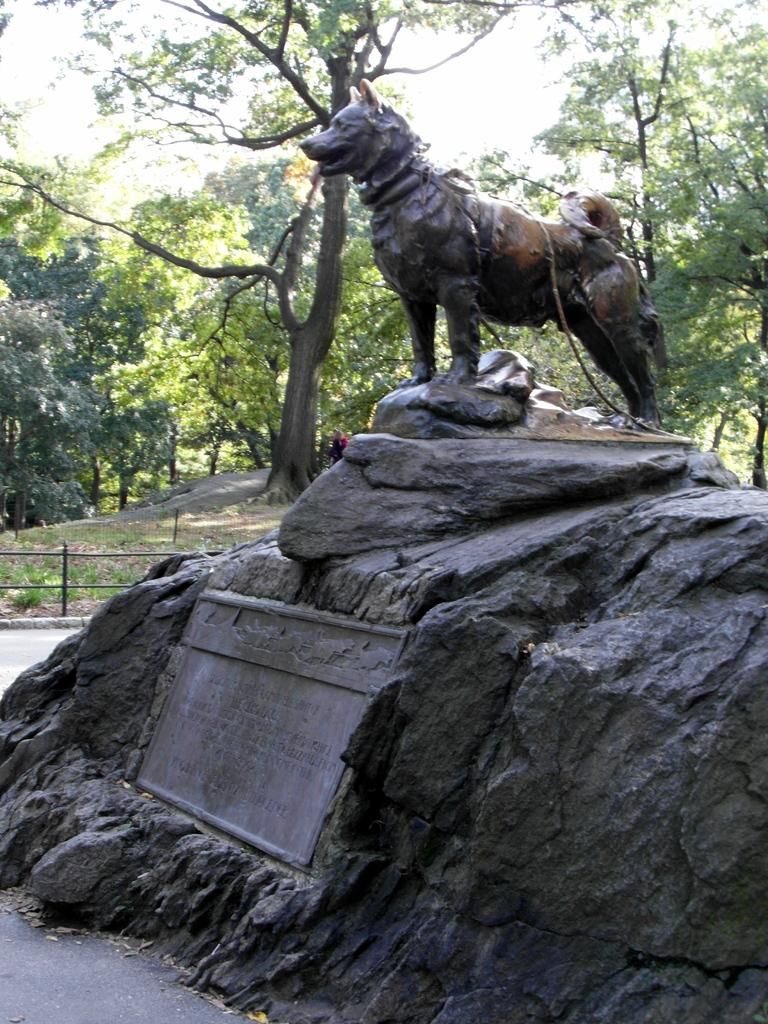What type of sculpture is depicted in the image? There is a sculpture of a dog in the image. What material is the sculpture made of? The sculpture is made of rock. What other object is present at the bottom of the image? There is a memorial stone at the bottom of the image. What can be seen in the background of the image? There are trees in the background of the image. What is visible at the top of the image? The sky is visible at the top of the image. How many boys are present in the image? There are no boys present in the image; it features a sculpture of a dog, a memorial stone, trees, and the sky. 